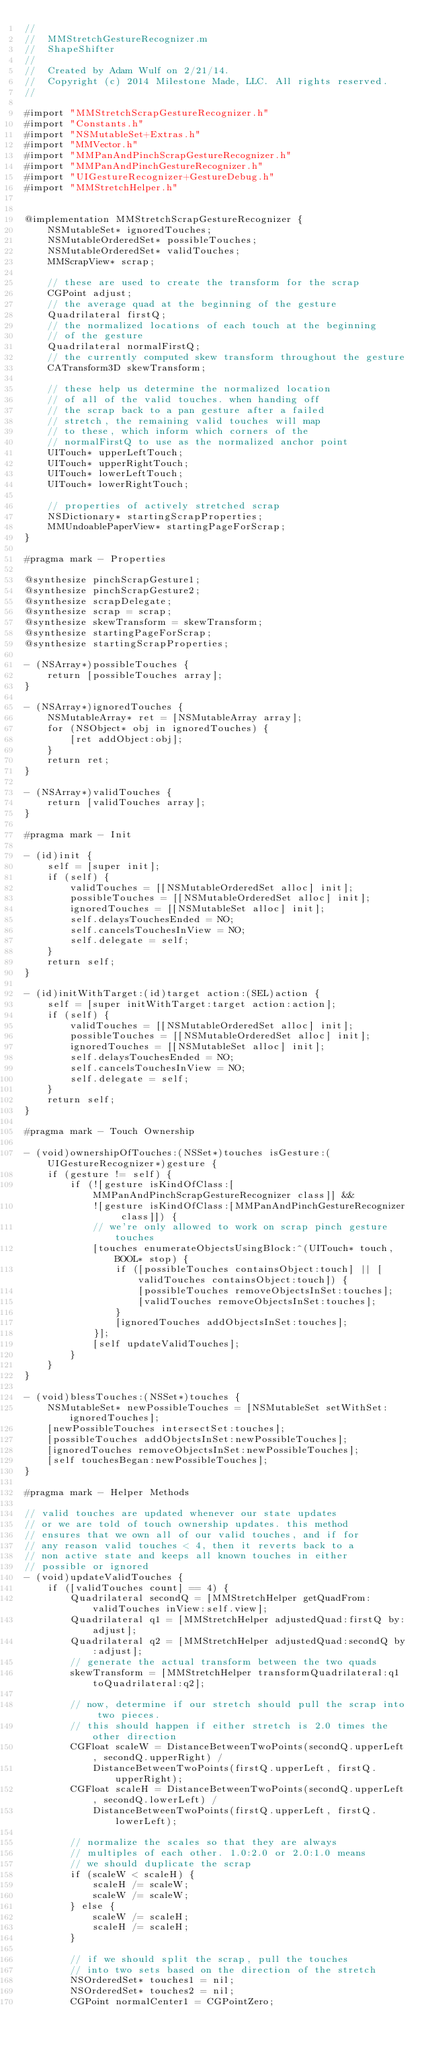<code> <loc_0><loc_0><loc_500><loc_500><_ObjectiveC_>//
//  MMStretchGestureRecognizer.m
//  ShapeShifter
//
//  Created by Adam Wulf on 2/21/14.
//  Copyright (c) 2014 Milestone Made, LLC. All rights reserved.
//

#import "MMStretchScrapGestureRecognizer.h"
#import "Constants.h"
#import "NSMutableSet+Extras.h"
#import "MMVector.h"
#import "MMPanAndPinchScrapGestureRecognizer.h"
#import "MMPanAndPinchGestureRecognizer.h"
#import "UIGestureRecognizer+GestureDebug.h"
#import "MMStretchHelper.h"


@implementation MMStretchScrapGestureRecognizer {
    NSMutableSet* ignoredTouches;
    NSMutableOrderedSet* possibleTouches;
    NSMutableOrderedSet* validTouches;
    MMScrapView* scrap;

    // these are used to create the transform for the scrap
    CGPoint adjust;
    // the average quad at the beginning of the gesture
    Quadrilateral firstQ;
    // the normalized locations of each touch at the beginning
    // of the gesture
    Quadrilateral normalFirstQ;
    // the currently computed skew transform throughout the gesture
    CATransform3D skewTransform;

    // these help us determine the normalized location
    // of all of the valid touches. when handing off
    // the scrap back to a pan gesture after a failed
    // stretch, the remaining valid touches will map
    // to these, which inform which corners of the
    // normalFirstQ to use as the normalized anchor point
    UITouch* upperLeftTouch;
    UITouch* upperRightTouch;
    UITouch* lowerLeftTouch;
    UITouch* lowerRightTouch;

    // properties of actively stretched scrap
    NSDictionary* startingScrapProperties;
    MMUndoablePaperView* startingPageForScrap;
}

#pragma mark - Properties

@synthesize pinchScrapGesture1;
@synthesize pinchScrapGesture2;
@synthesize scrapDelegate;
@synthesize scrap = scrap;
@synthesize skewTransform = skewTransform;
@synthesize startingPageForScrap;
@synthesize startingScrapProperties;

- (NSArray*)possibleTouches {
    return [possibleTouches array];
}

- (NSArray*)ignoredTouches {
    NSMutableArray* ret = [NSMutableArray array];
    for (NSObject* obj in ignoredTouches) {
        [ret addObject:obj];
    }
    return ret;
}

- (NSArray*)validTouches {
    return [validTouches array];
}

#pragma mark - Init

- (id)init {
    self = [super init];
    if (self) {
        validTouches = [[NSMutableOrderedSet alloc] init];
        possibleTouches = [[NSMutableOrderedSet alloc] init];
        ignoredTouches = [[NSMutableSet alloc] init];
        self.delaysTouchesEnded = NO;
        self.cancelsTouchesInView = NO;
        self.delegate = self;
    }
    return self;
}

- (id)initWithTarget:(id)target action:(SEL)action {
    self = [super initWithTarget:target action:action];
    if (self) {
        validTouches = [[NSMutableOrderedSet alloc] init];
        possibleTouches = [[NSMutableOrderedSet alloc] init];
        ignoredTouches = [[NSMutableSet alloc] init];
        self.delaysTouchesEnded = NO;
        self.cancelsTouchesInView = NO;
        self.delegate = self;
    }
    return self;
}

#pragma mark - Touch Ownership

- (void)ownershipOfTouches:(NSSet*)touches isGesture:(UIGestureRecognizer*)gesture {
    if (gesture != self) {
        if (![gesture isKindOfClass:[MMPanAndPinchScrapGestureRecognizer class]] &&
            ![gesture isKindOfClass:[MMPanAndPinchGestureRecognizer class]]) {
            // we're only allowed to work on scrap pinch gesture touches
            [touches enumerateObjectsUsingBlock:^(UITouch* touch, BOOL* stop) {
                if ([possibleTouches containsObject:touch] || [validTouches containsObject:touch]) {
                    [possibleTouches removeObjectsInSet:touches];
                    [validTouches removeObjectsInSet:touches];
                }
                [ignoredTouches addObjectsInSet:touches];
            }];
            [self updateValidTouches];
        }
    }
}

- (void)blessTouches:(NSSet*)touches {
    NSMutableSet* newPossibleTouches = [NSMutableSet setWithSet:ignoredTouches];
    [newPossibleTouches intersectSet:touches];
    [possibleTouches addObjectsInSet:newPossibleTouches];
    [ignoredTouches removeObjectsInSet:newPossibleTouches];
    [self touchesBegan:newPossibleTouches];
}

#pragma mark - Helper Methods

// valid touches are updated whenever our state updates
// or we are told of touch ownership updates. this method
// ensures that we own all of our valid touches, and if for
// any reason valid touches < 4, then it reverts back to a
// non active state and keeps all known touches in either
// possible or ignored
- (void)updateValidTouches {
    if ([validTouches count] == 4) {
        Quadrilateral secondQ = [MMStretchHelper getQuadFrom:validTouches inView:self.view];
        Quadrilateral q1 = [MMStretchHelper adjustedQuad:firstQ by:adjust];
        Quadrilateral q2 = [MMStretchHelper adjustedQuad:secondQ by:adjust];
        // generate the actual transform between the two quads
        skewTransform = [MMStretchHelper transformQuadrilateral:q1 toQuadrilateral:q2];

        // now, determine if our stretch should pull the scrap into two pieces.
        // this should happen if either stretch is 2.0 times the other direction
        CGFloat scaleW = DistanceBetweenTwoPoints(secondQ.upperLeft, secondQ.upperRight) /
            DistanceBetweenTwoPoints(firstQ.upperLeft, firstQ.upperRight);
        CGFloat scaleH = DistanceBetweenTwoPoints(secondQ.upperLeft, secondQ.lowerLeft) /
            DistanceBetweenTwoPoints(firstQ.upperLeft, firstQ.lowerLeft);

        // normalize the scales so that they are always
        // multiples of each other. 1.0:2.0 or 2.0:1.0 means
        // we should duplicate the scrap
        if (scaleW < scaleH) {
            scaleH /= scaleW;
            scaleW /= scaleW;
        } else {
            scaleW /= scaleH;
            scaleH /= scaleH;
        }

        // if we should split the scrap, pull the touches
        // into two sets based on the direction of the stretch
        NSOrderedSet* touches1 = nil;
        NSOrderedSet* touches2 = nil;
        CGPoint normalCenter1 = CGPointZero;</code> 